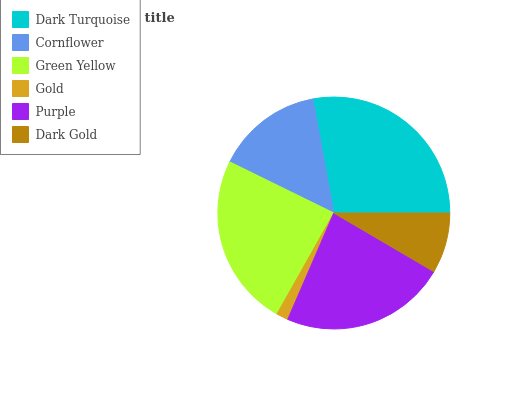Is Gold the minimum?
Answer yes or no. Yes. Is Dark Turquoise the maximum?
Answer yes or no. Yes. Is Cornflower the minimum?
Answer yes or no. No. Is Cornflower the maximum?
Answer yes or no. No. Is Dark Turquoise greater than Cornflower?
Answer yes or no. Yes. Is Cornflower less than Dark Turquoise?
Answer yes or no. Yes. Is Cornflower greater than Dark Turquoise?
Answer yes or no. No. Is Dark Turquoise less than Cornflower?
Answer yes or no. No. Is Purple the high median?
Answer yes or no. Yes. Is Cornflower the low median?
Answer yes or no. Yes. Is Cornflower the high median?
Answer yes or no. No. Is Green Yellow the low median?
Answer yes or no. No. 